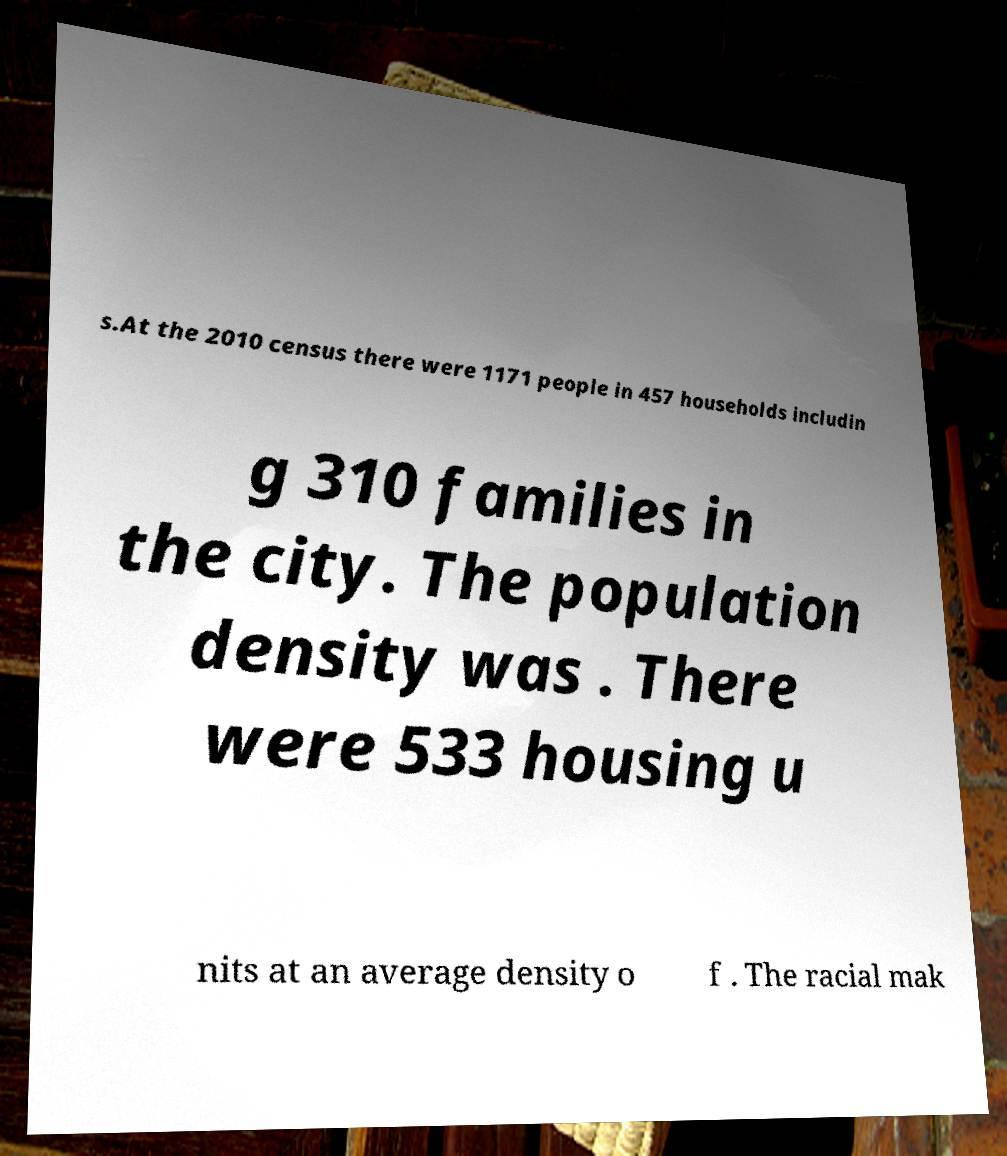What messages or text are displayed in this image? I need them in a readable, typed format. s.At the 2010 census there were 1171 people in 457 households includin g 310 families in the city. The population density was . There were 533 housing u nits at an average density o f . The racial mak 